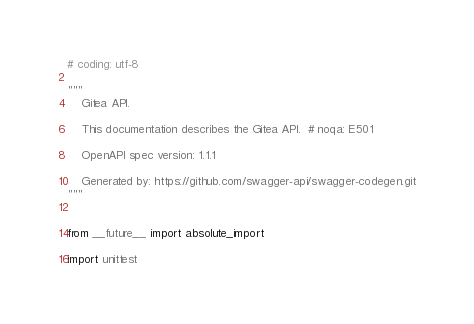<code> <loc_0><loc_0><loc_500><loc_500><_Python_># coding: utf-8

"""
    Gitea API.

    This documentation describes the Gitea API.  # noqa: E501

    OpenAPI spec version: 1.1.1
    
    Generated by: https://github.com/swagger-api/swagger-codegen.git
"""


from __future__ import absolute_import

import unittest
</code> 